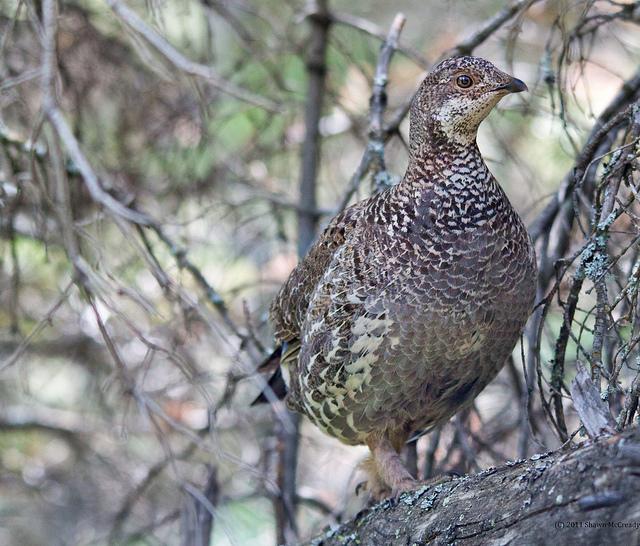What is the bird standing on?
Keep it brief. Branch. Does this look like a chicken?
Quick response, please. No. Indoors or outside?
Answer briefly. Outside. 